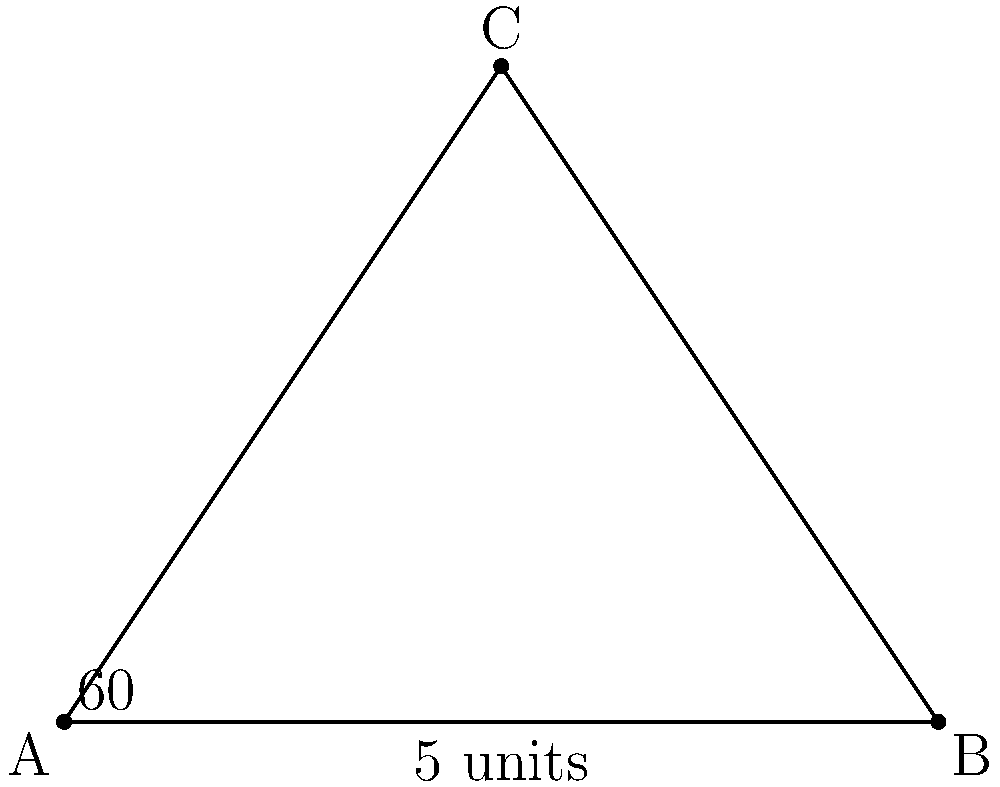Your ancestors built two ancient settlements, represented by points A and C in the diagram. A third settlement, point B, forms a triangle with A and C. If the distance between A and B is 5 units and the angle at A is 60°, what is the distance between the settlements at A and C? To find the distance between settlements A and C, we can use the law of sines. Let's approach this step-by-step:

1) In triangle ABC, we know:
   - The distance AB = 5 units
   - Angle A = 60°

2) The law of sines states: 
   $$\frac{a}{\sin A} = \frac{b}{\sin B} = \frac{c}{\sin C}$$
   where a, b, and c are the lengths of the sides opposite to angles A, B, and C respectively.

3) We want to find AC, which is side b in this case. We can use:
   $$\frac{AB}{\sin C} = \frac{AC}{\sin 60°}$$

4) We know AB and sin 60°, but we need to find sin C. We can do this using the fact that the sum of angles in a triangle is 180°:
   
   Angle C = 180° - 60° - Angle B
   
   But we don't know Angle B. However, we can find it using the sine rule again:
   
   $$\frac{AB}{\sin 60°} = \frac{BC}{\sin 60°}$$
   
   This means AB = BC = 5 units. So this is an isosceles triangle, and Angle B must also be 60°.

5) Therefore, Angle C = 180° - 60° - 60° = 60°

6) Now we can solve for AC:
   $$\frac{5}{\sin 60°} = \frac{AC}{\sin 60°}$$

7) This simplifies to AC = 5 units

Therefore, the distance between settlements A and C is 5 units.
Answer: 5 units 